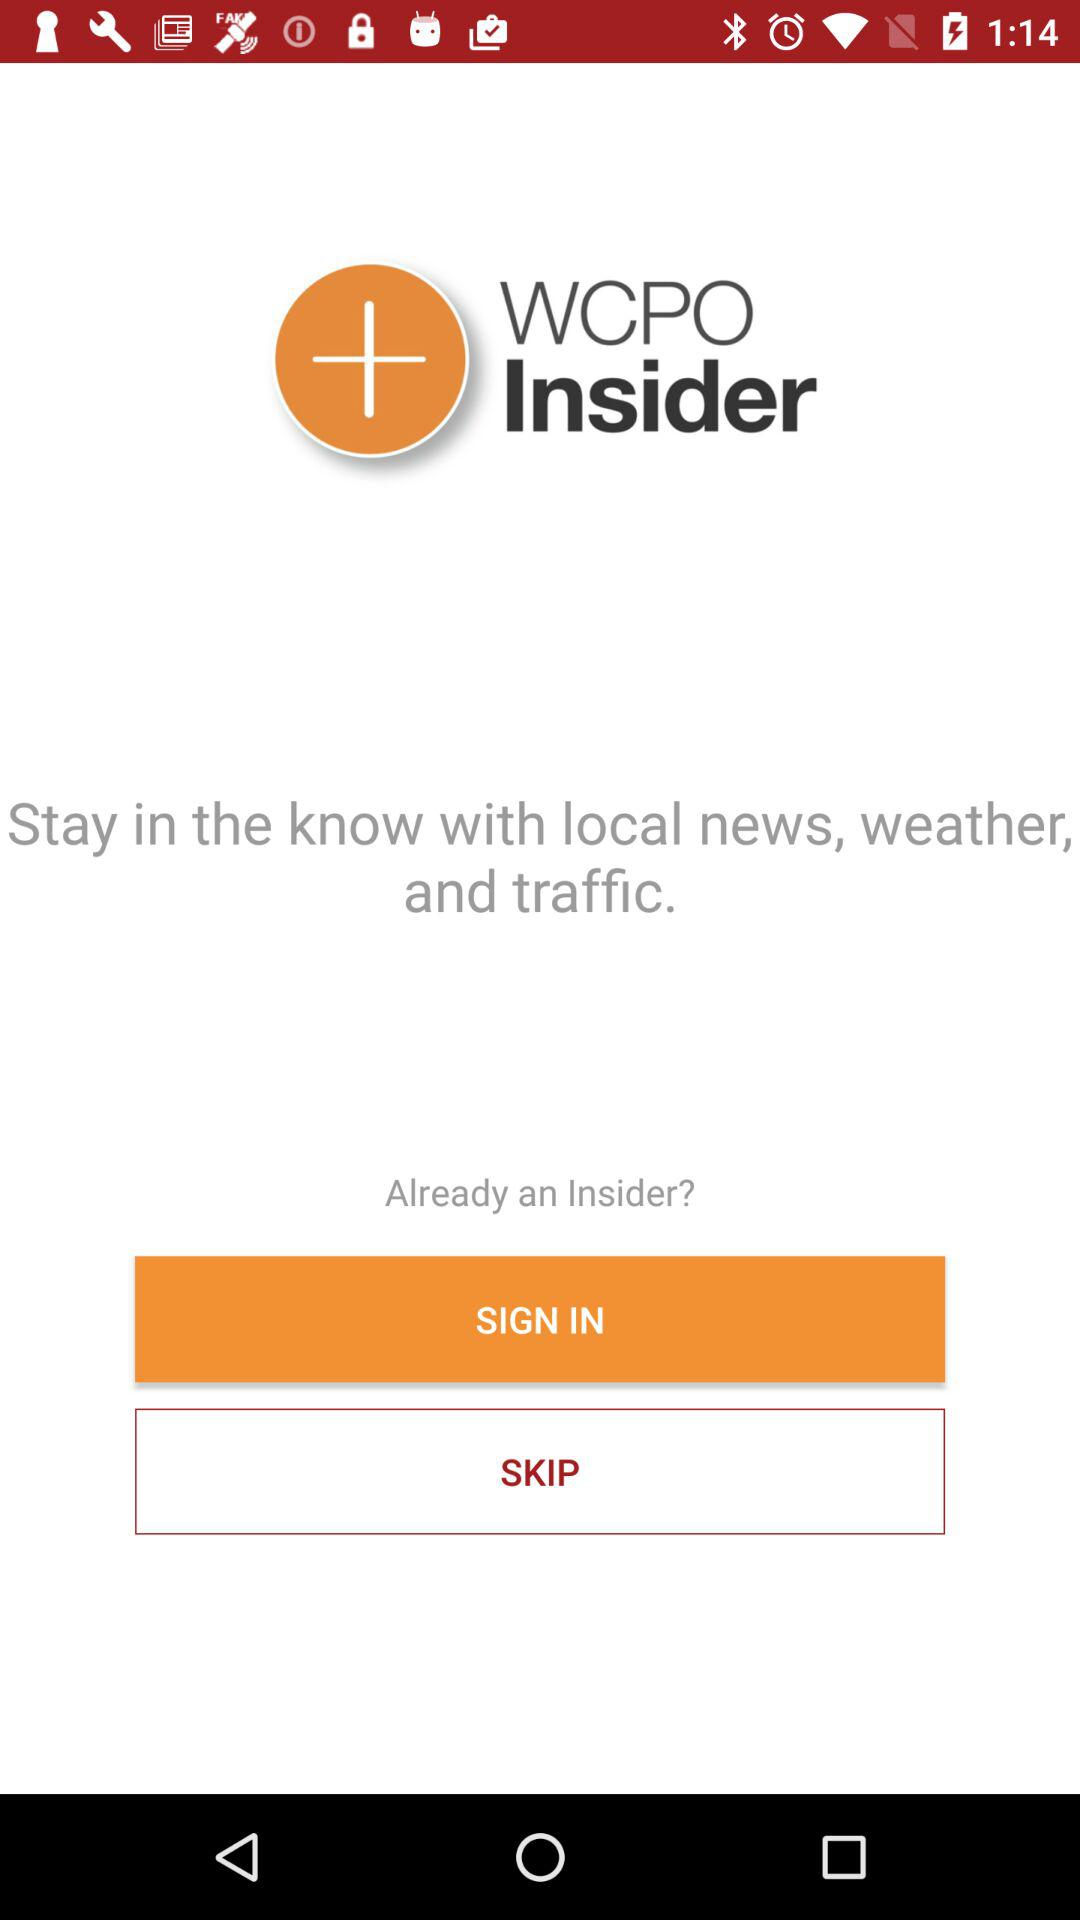What is the app name? The app name is "WCPO Insider". 